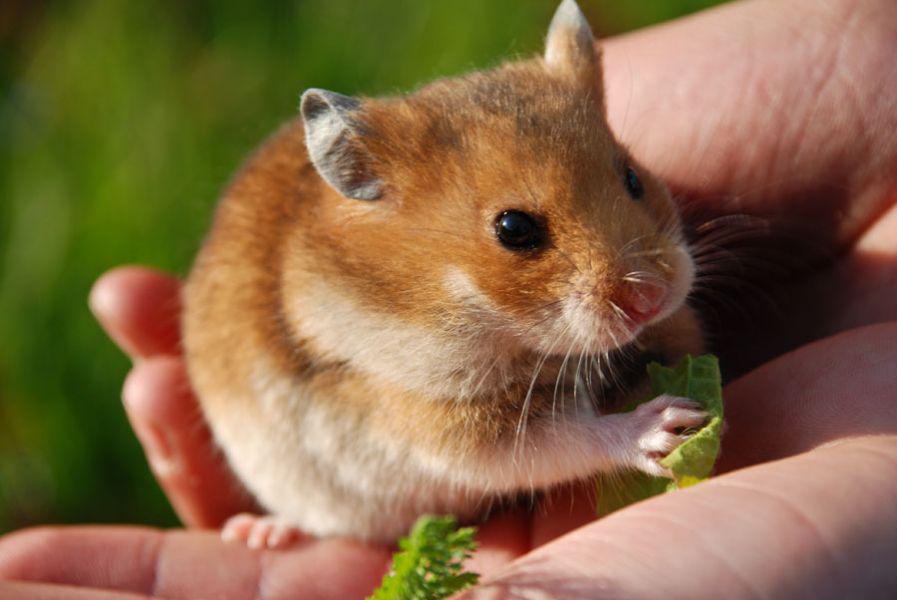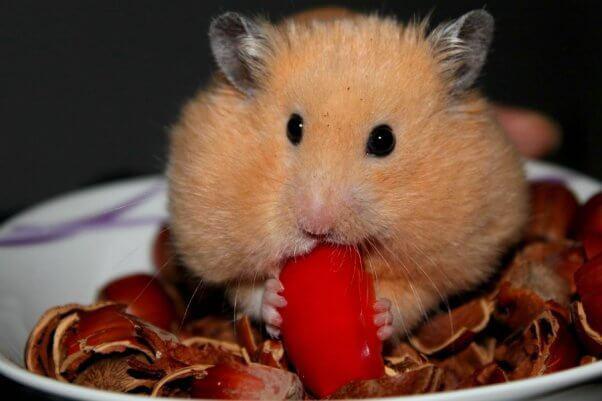The first image is the image on the left, the second image is the image on the right. Given the left and right images, does the statement "In at least one of the images, the hamster is holding food" hold true? Answer yes or no. Yes. 